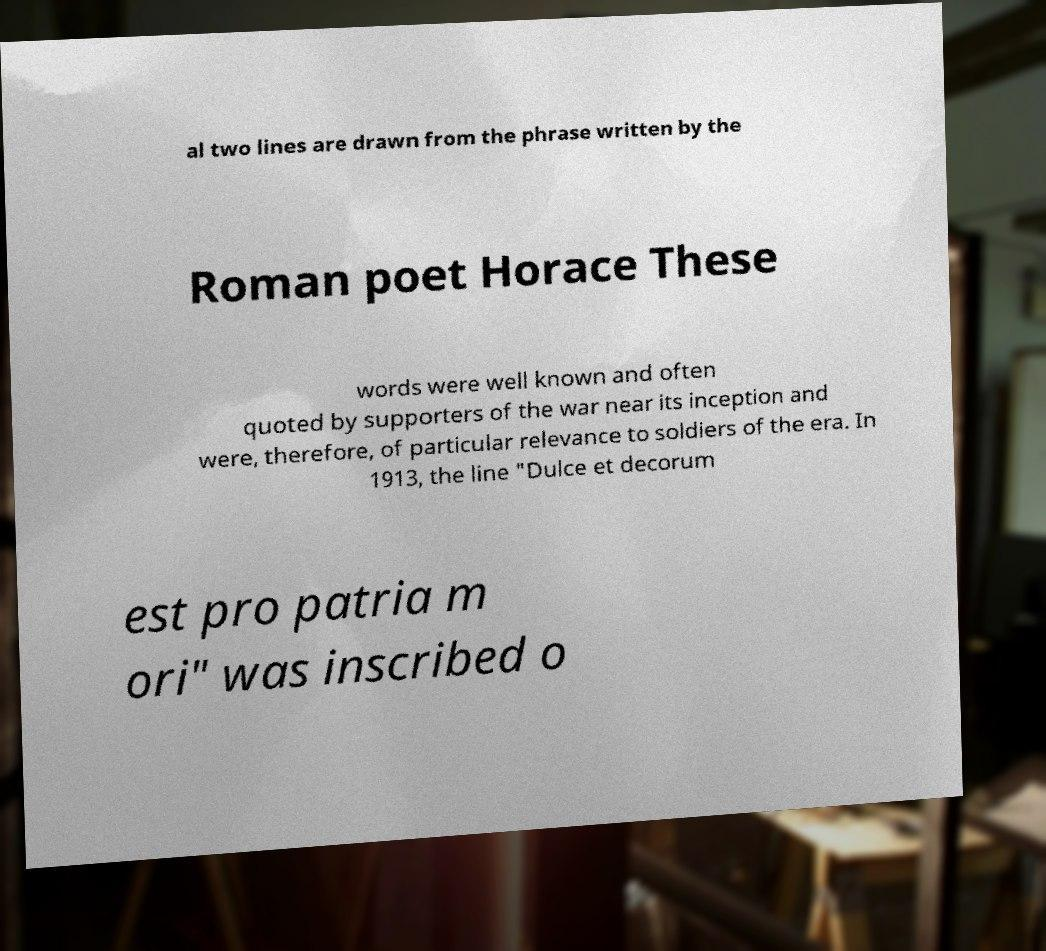Could you assist in decoding the text presented in this image and type it out clearly? al two lines are drawn from the phrase written by the Roman poet Horace These words were well known and often quoted by supporters of the war near its inception and were, therefore, of particular relevance to soldiers of the era. In 1913, the line "Dulce et decorum est pro patria m ori" was inscribed o 